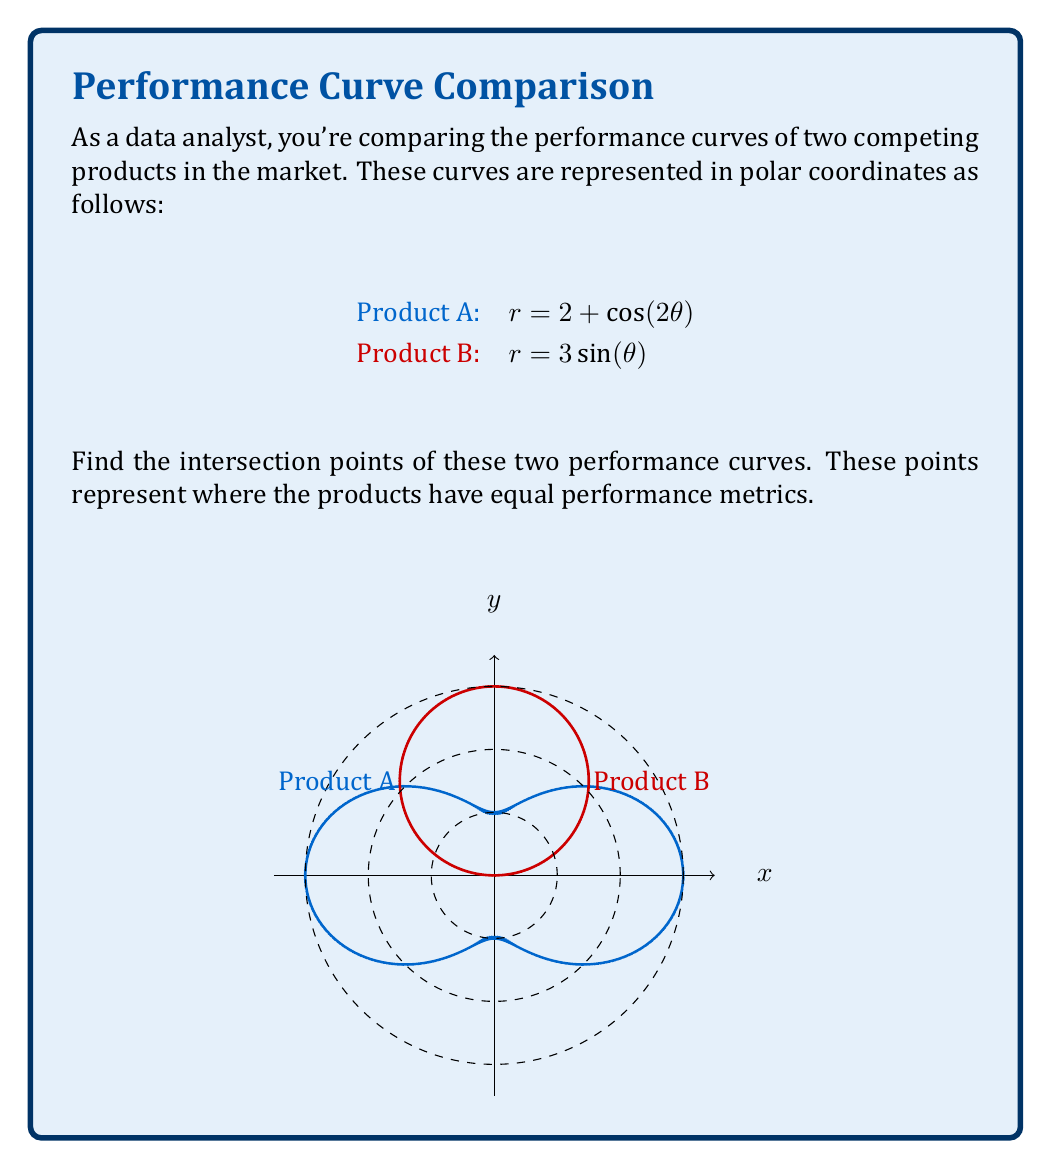What is the answer to this math problem? To find the intersection points, we need to solve the equation:

$$2 + \cos(2\theta) = 3\sin(\theta)$$

1) First, let's use the double angle formula for cosine:
   $\cos(2\theta) = 1 - 2\sin^2(\theta)$

2) Substituting this into our original equation:
   $2 + (1 - 2\sin^2(\theta)) = 3\sin(\theta)$

3) Simplify:
   $3 - 2\sin^2(\theta) = 3\sin(\theta)$

4) Rearrange:
   $2\sin^2(\theta) + 3\sin(\theta) - 3 = 0$

5) This is a quadratic equation in terms of $\sin(\theta)$. Let $u = \sin(\theta)$:
   $2u^2 + 3u - 3 = 0$

6) Solve using the quadratic formula $u = \frac{-b \pm \sqrt{b^2 - 4ac}}{2a}$:
   $u = \frac{-3 \pm \sqrt{9 + 24}}{4} = \frac{-3 \pm \sqrt{33}}{4}$

7) Therefore:
   $\sin(\theta) = \frac{-3 + \sqrt{33}}{4}$ or $\sin(\theta) = \frac{-3 - \sqrt{33}}{4}$

8) The second solution is less than -1, which is not possible for sine. So we only consider the first solution.

9) $\theta = \arcsin(\frac{-3 + \sqrt{33}}{4})$ ≈ 0.5389 radians or 30.87°

10) Due to the symmetry of the curves, there will be four intersection points in total, at angles:
    $\theta_1 = 0.5389$, $\theta_2 = \pi - 0.5389$, $\theta_3 = \pi + 0.5389$, $\theta_4 = 2\pi - 0.5389$

11) To find the r-coordinates, substitute these θ values into either of the original equations.
Answer: $(r,\theta) = (2.614, 0.5389)$, $(2.614, 2.6027)$, $(2.614, 3.6803)$, $(2.614, 5.7441)$ 